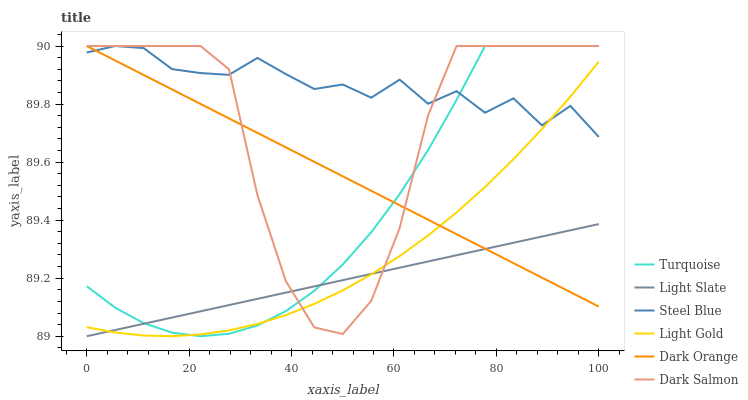Does Light Slate have the minimum area under the curve?
Answer yes or no. Yes. Does Steel Blue have the maximum area under the curve?
Answer yes or no. Yes. Does Turquoise have the minimum area under the curve?
Answer yes or no. No. Does Turquoise have the maximum area under the curve?
Answer yes or no. No. Is Dark Orange the smoothest?
Answer yes or no. Yes. Is Dark Salmon the roughest?
Answer yes or no. Yes. Is Turquoise the smoothest?
Answer yes or no. No. Is Turquoise the roughest?
Answer yes or no. No. Does Light Slate have the lowest value?
Answer yes or no. Yes. Does Turquoise have the lowest value?
Answer yes or no. No. Does Dark Salmon have the highest value?
Answer yes or no. Yes. Does Light Slate have the highest value?
Answer yes or no. No. Is Light Slate less than Steel Blue?
Answer yes or no. Yes. Is Steel Blue greater than Light Slate?
Answer yes or no. Yes. Does Dark Orange intersect Light Gold?
Answer yes or no. Yes. Is Dark Orange less than Light Gold?
Answer yes or no. No. Is Dark Orange greater than Light Gold?
Answer yes or no. No. Does Light Slate intersect Steel Blue?
Answer yes or no. No. 